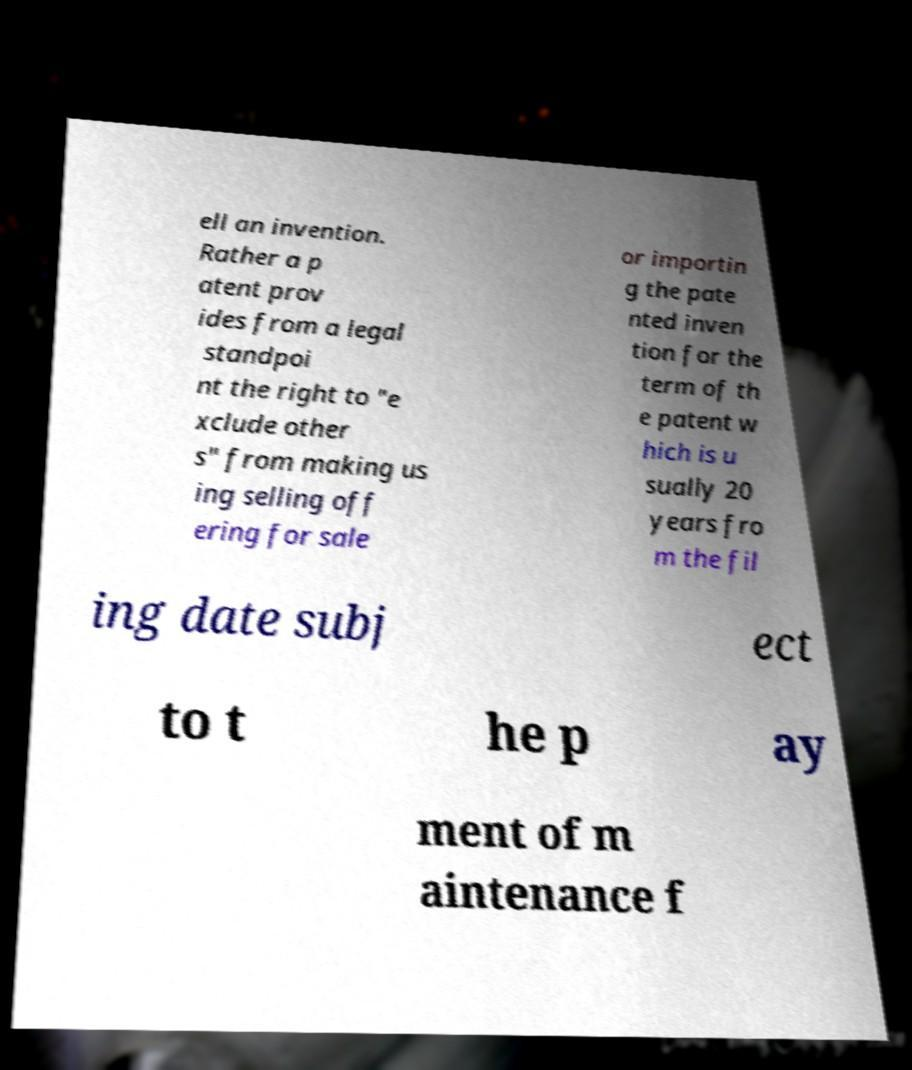Can you accurately transcribe the text from the provided image for me? ell an invention. Rather a p atent prov ides from a legal standpoi nt the right to "e xclude other s" from making us ing selling off ering for sale or importin g the pate nted inven tion for the term of th e patent w hich is u sually 20 years fro m the fil ing date subj ect to t he p ay ment of m aintenance f 